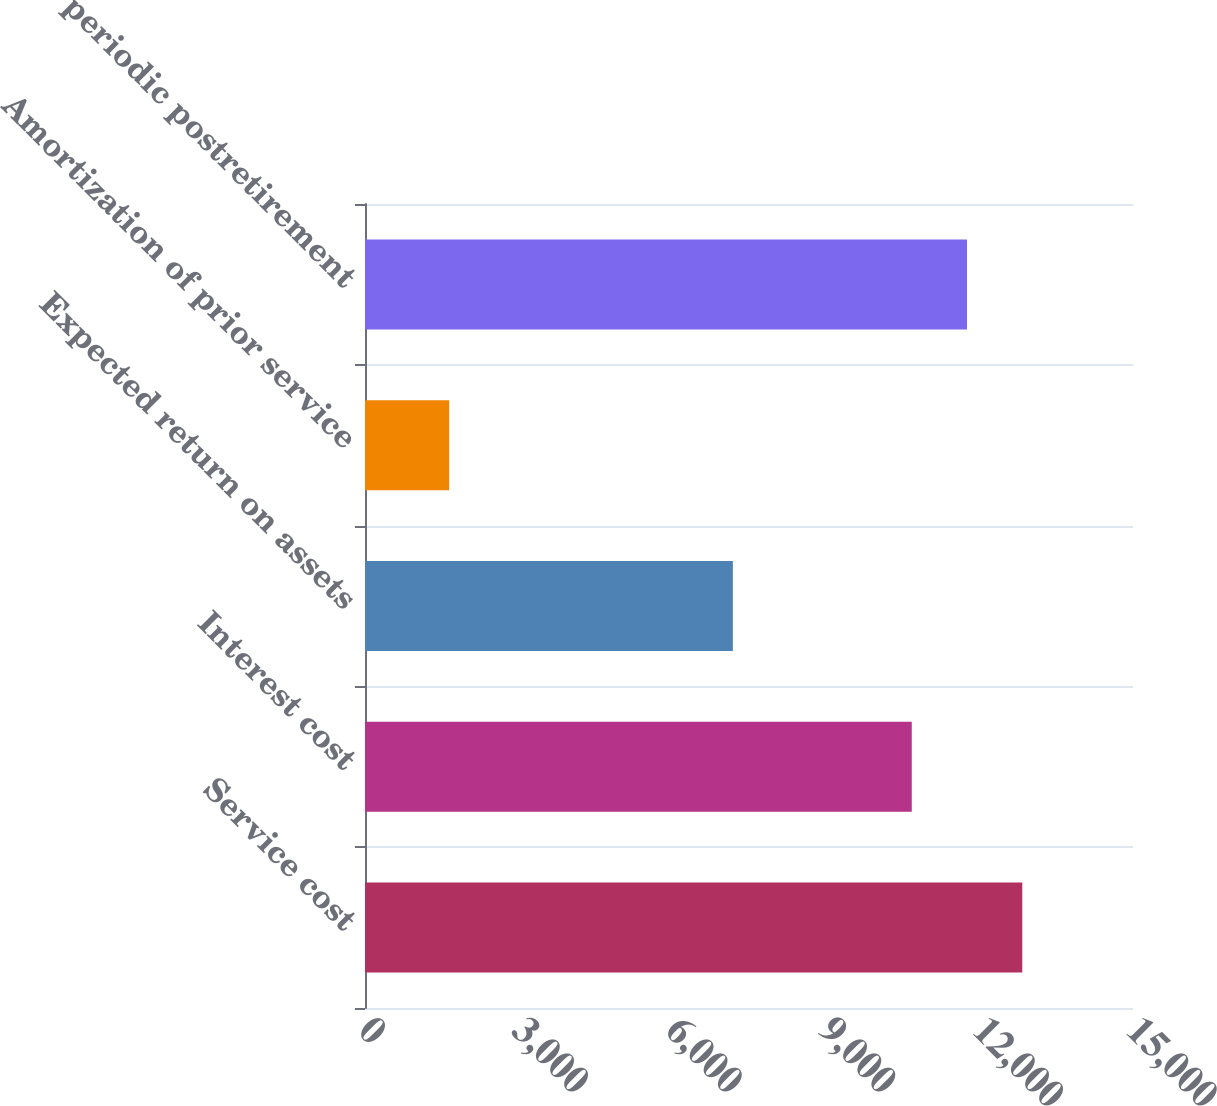Convert chart. <chart><loc_0><loc_0><loc_500><loc_500><bar_chart><fcel>Service cost<fcel>Interest cost<fcel>Expected return on assets<fcel>Amortization of prior service<fcel>Net periodic postretirement<nl><fcel>12837.4<fcel>10679<fcel>7185<fcel>1644<fcel>11758.2<nl></chart> 